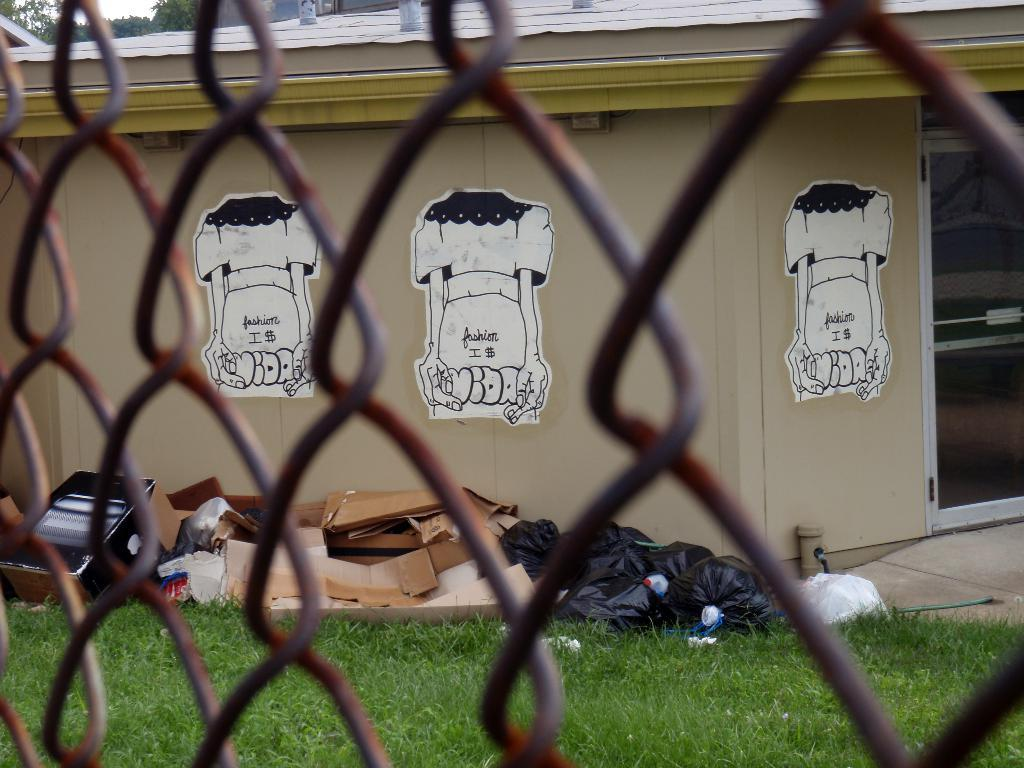What is located at the front of the image? There is a metal fence in the front of the image. What can be seen in the back of the image? There is a wall with images in the back of the image. What type of surface is the floor made of? The floor is made of grass. What is placed in front of the wall? There are cardboards in front of the wall. What sense is being stimulated by the growth of the cardboards in the image? There is no growth of cardboards in the image, and therefore no sense is being stimulated. What effect does the metal fence have on the wall in the image? The metal fence is located in the front of the image, and it does not have any direct effect on the wall in the back of the image. 